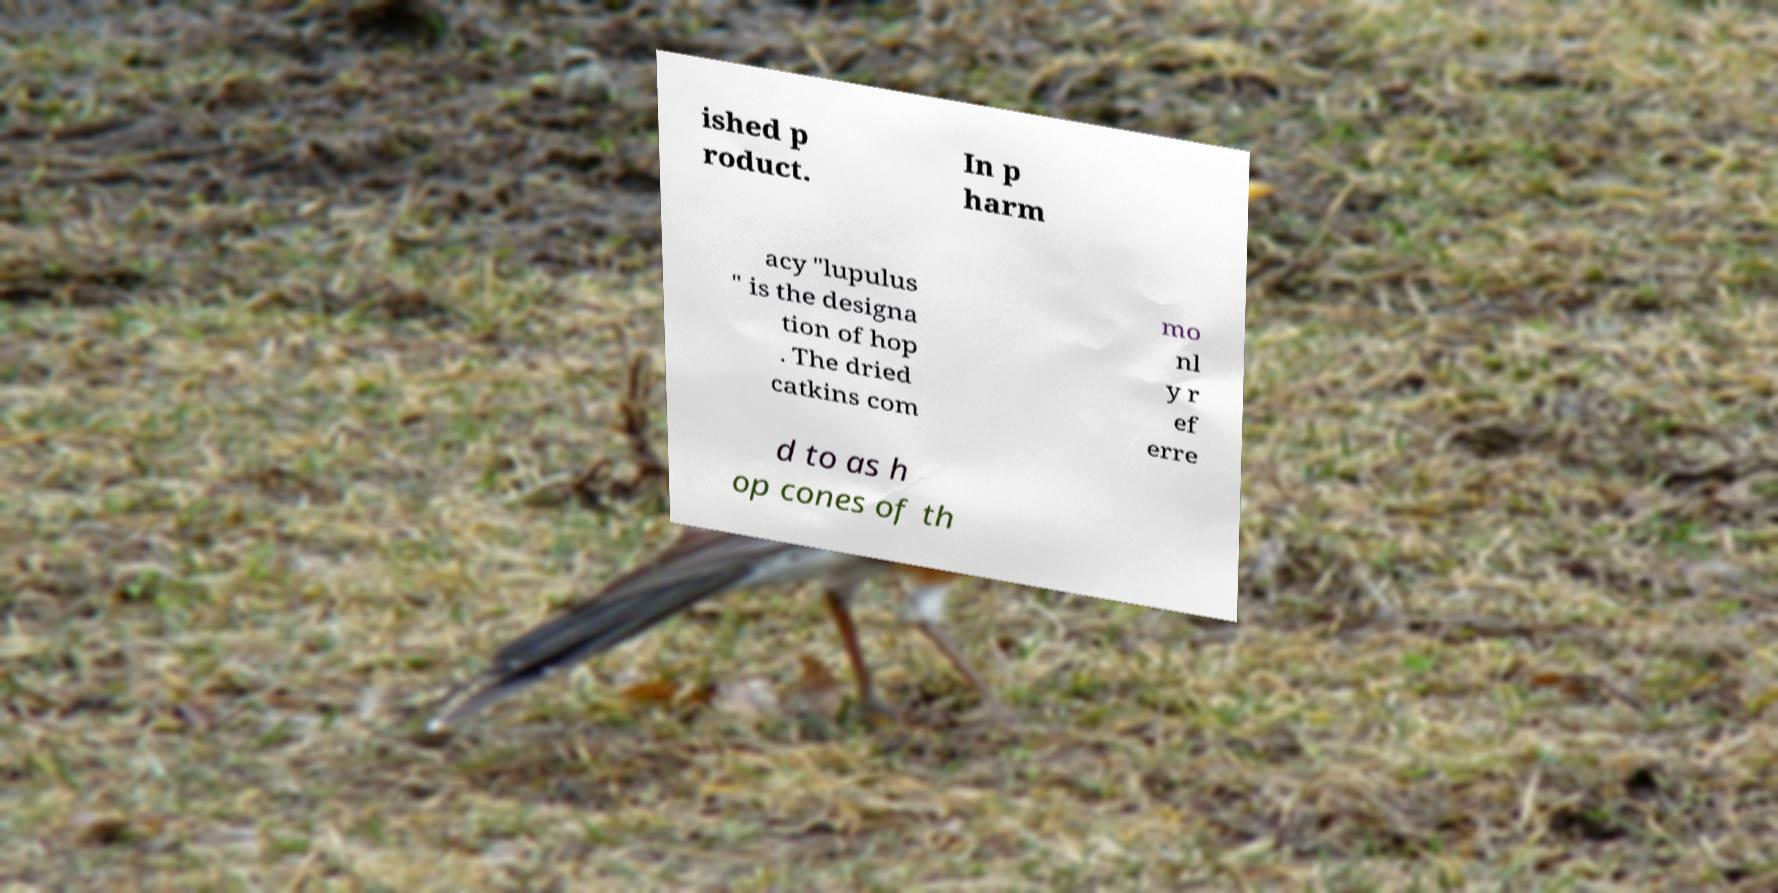Could you assist in decoding the text presented in this image and type it out clearly? ished p roduct. In p harm acy "lupulus " is the designa tion of hop . The dried catkins com mo nl y r ef erre d to as h op cones of th 